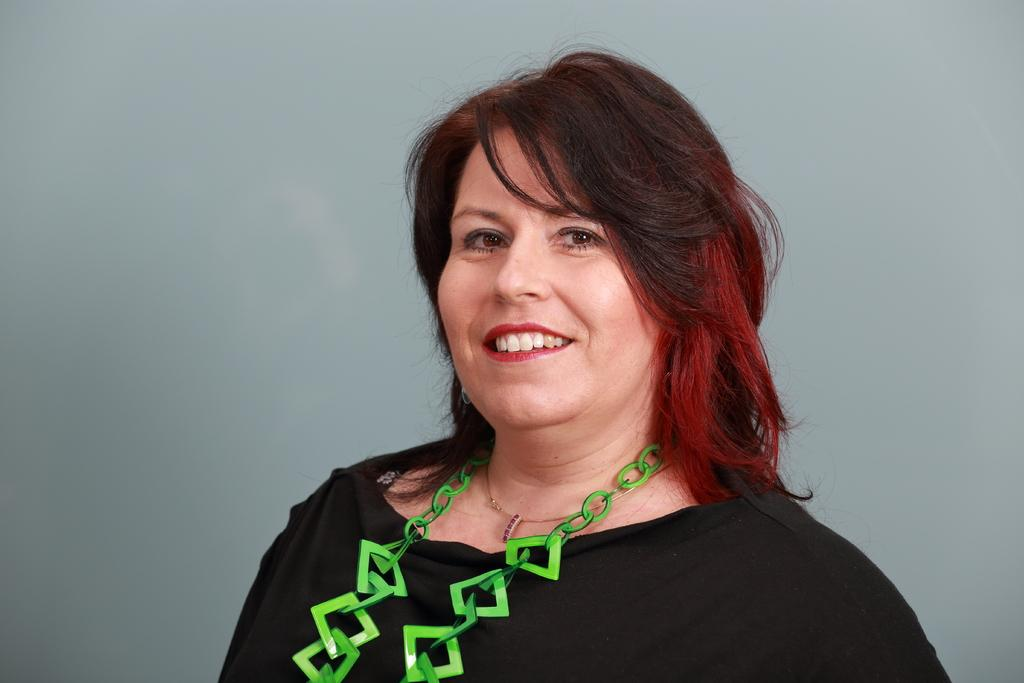What is the main subject of the image? There is a woman in the image. Can you describe any accessories the woman is wearing? The woman is wearing a green necklace. What type of trade is being conducted in the image? There is no trade being conducted in the image; it features a woman wearing a green necklace. Where is the tray located in the image? There is no tray present in the image. 